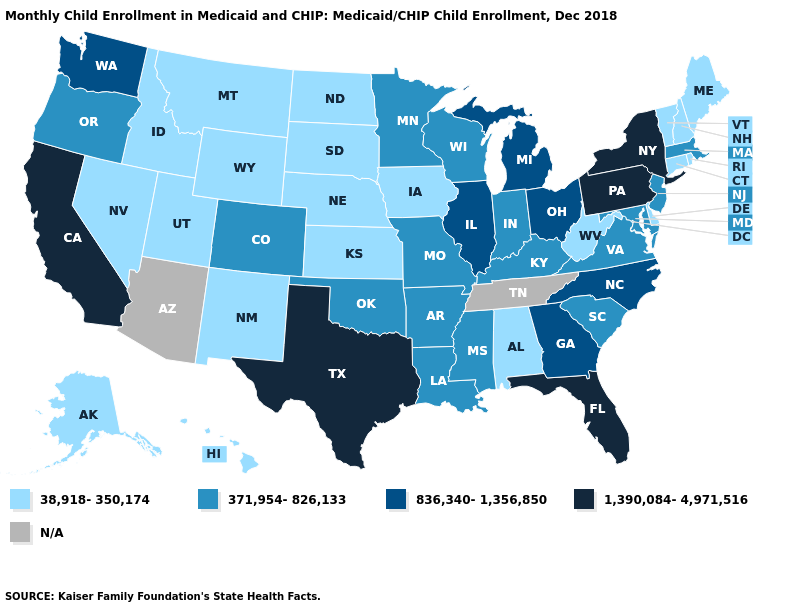Which states hav the highest value in the Northeast?
Quick response, please. New York, Pennsylvania. What is the lowest value in states that border Connecticut?
Give a very brief answer. 38,918-350,174. What is the value of Virginia?
Short answer required. 371,954-826,133. What is the value of Connecticut?
Keep it brief. 38,918-350,174. Is the legend a continuous bar?
Write a very short answer. No. Among the states that border Kansas , which have the lowest value?
Answer briefly. Nebraska. Name the states that have a value in the range 836,340-1,356,850?
Keep it brief. Georgia, Illinois, Michigan, North Carolina, Ohio, Washington. Name the states that have a value in the range 38,918-350,174?
Be succinct. Alabama, Alaska, Connecticut, Delaware, Hawaii, Idaho, Iowa, Kansas, Maine, Montana, Nebraska, Nevada, New Hampshire, New Mexico, North Dakota, Rhode Island, South Dakota, Utah, Vermont, West Virginia, Wyoming. Does Pennsylvania have the lowest value in the USA?
Be succinct. No. What is the value of Connecticut?
Concise answer only. 38,918-350,174. Does West Virginia have the lowest value in the USA?
Give a very brief answer. Yes. Name the states that have a value in the range 371,954-826,133?
Be succinct. Arkansas, Colorado, Indiana, Kentucky, Louisiana, Maryland, Massachusetts, Minnesota, Mississippi, Missouri, New Jersey, Oklahoma, Oregon, South Carolina, Virginia, Wisconsin. Among the states that border Indiana , which have the highest value?
Give a very brief answer. Illinois, Michigan, Ohio. What is the value of North Carolina?
Short answer required. 836,340-1,356,850. Among the states that border Louisiana , does Texas have the highest value?
Quick response, please. Yes. 